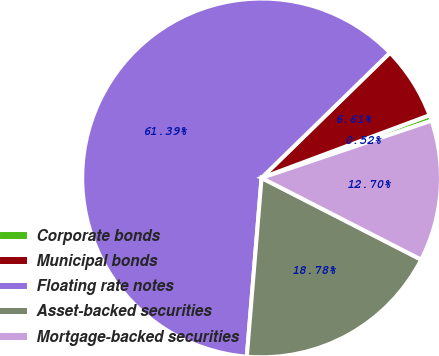Convert chart to OTSL. <chart><loc_0><loc_0><loc_500><loc_500><pie_chart><fcel>Corporate bonds<fcel>Municipal bonds<fcel>Floating rate notes<fcel>Asset-backed securities<fcel>Mortgage-backed securities<nl><fcel>0.52%<fcel>6.61%<fcel>61.39%<fcel>18.78%<fcel>12.7%<nl></chart> 